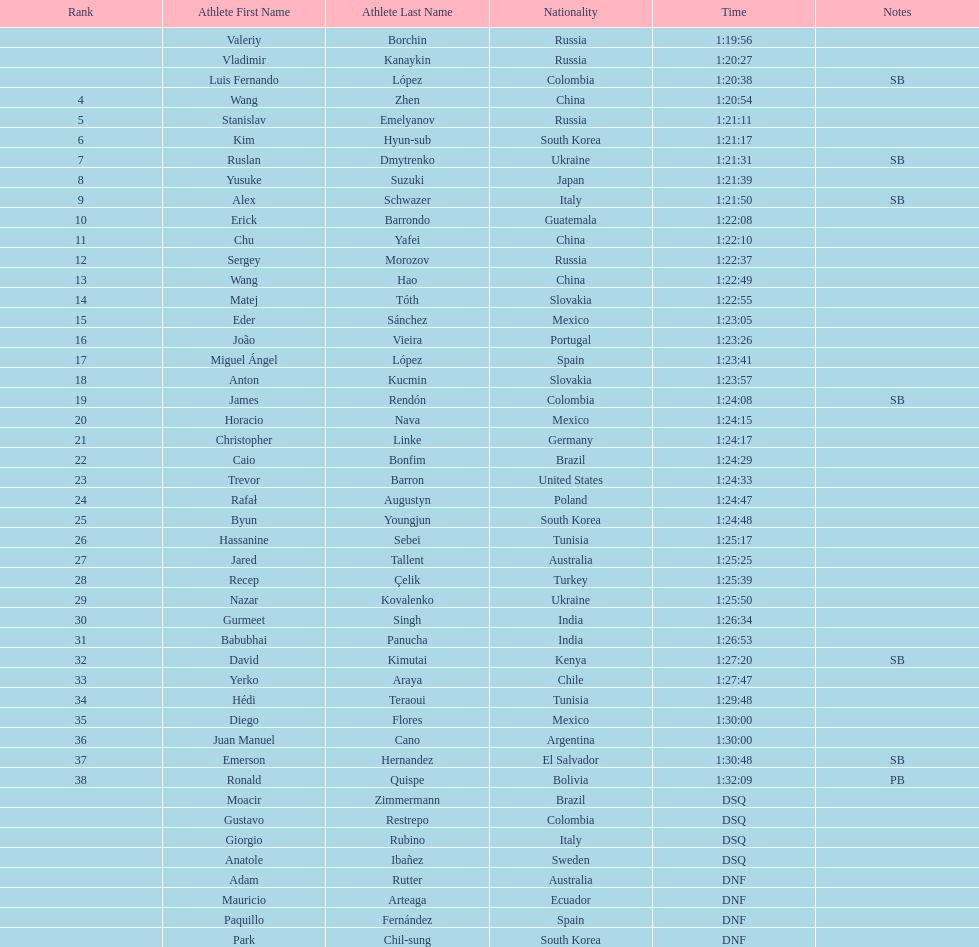Which competitor was ranked first? Valeriy Borchin. 